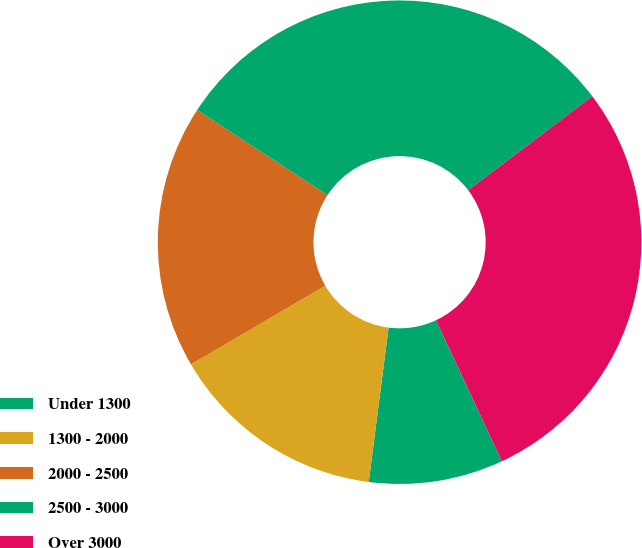Convert chart to OTSL. <chart><loc_0><loc_0><loc_500><loc_500><pie_chart><fcel>Under 1300<fcel>1300 - 2000<fcel>2000 - 2500<fcel>2500 - 3000<fcel>Over 3000<nl><fcel>8.99%<fcel>14.53%<fcel>17.64%<fcel>30.47%<fcel>28.36%<nl></chart> 